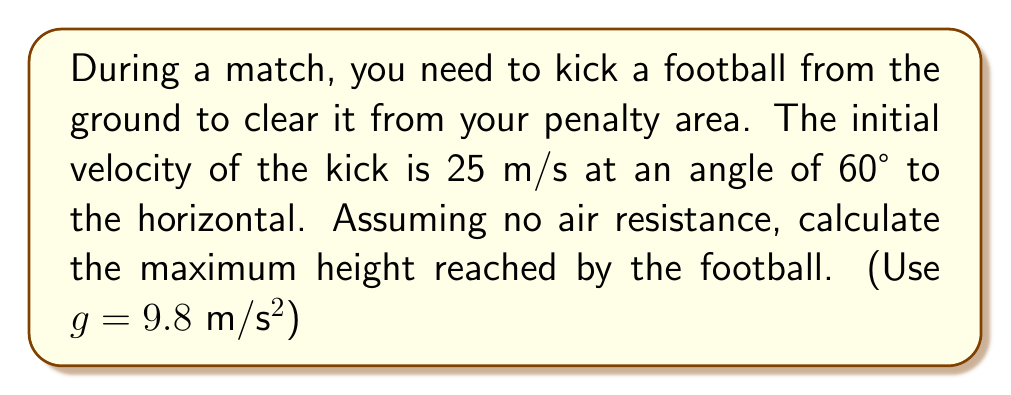Can you answer this question? To solve this problem, we'll use the equations of motion for projectile motion. Let's break it down step-by-step:

1) The initial velocity components are:
   $v_{0x} = v_0 \cos \theta = 25 \cos 60° = 12.5$ m/s
   $v_{0y} = v_0 \sin \theta = 25 \sin 60° = 21.65$ m/s

2) The maximum height is reached when the vertical velocity ($v_y$) becomes zero. We can use the equation:
   $$v_y^2 = v_{0y}^2 - 2gh_{max}$$

3) At the highest point, $v_y = 0$, so:
   $$0 = v_{0y}^2 - 2gh_{max}$$

4) Rearranging to solve for $h_{max}$:
   $$h_{max} = \frac{v_{0y}^2}{2g}$$

5) Substituting the values:
   $$h_{max} = \frac{(21.65)^2}{2(9.8)} = \frac{468.72}{19.6} = 23.91$$ m

Therefore, the maximum height reached by the football is approximately 23.91 meters.
Answer: 23.91 m 